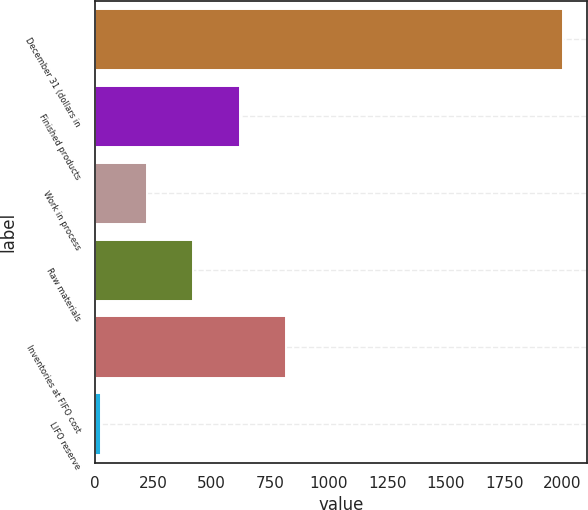Convert chart to OTSL. <chart><loc_0><loc_0><loc_500><loc_500><bar_chart><fcel>December 31 (dollars in<fcel>Finished products<fcel>Work in process<fcel>Raw materials<fcel>Inventories at FIFO cost<fcel>LIFO reserve<nl><fcel>2003<fcel>618.96<fcel>223.52<fcel>421.24<fcel>816.68<fcel>25.8<nl></chart> 